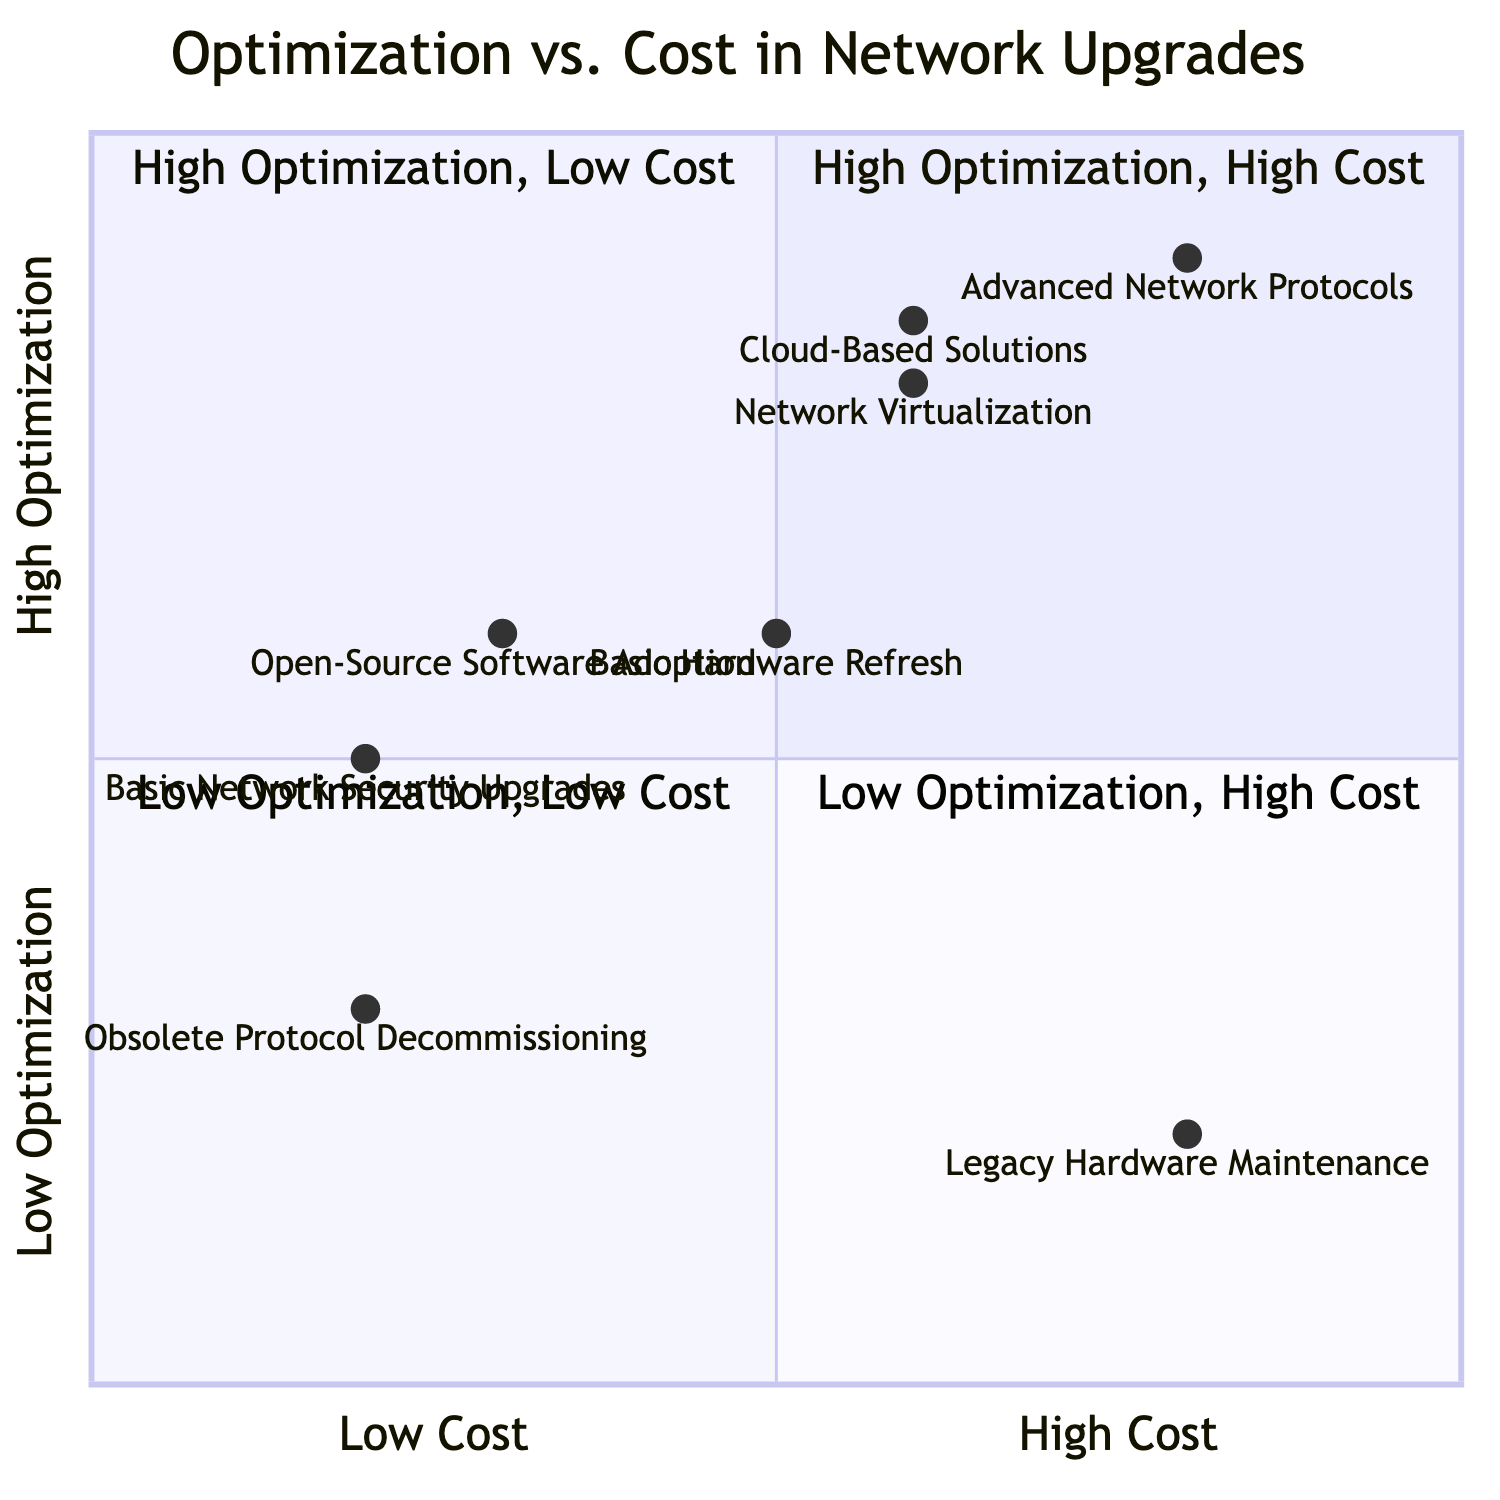What element is located in the High Optimization, High Cost quadrant? The diagram identifies "Advanced Network Protocols" as the only element in this quadrant.
Answer: Advanced Network Protocols How many elements fall under Low Cost? By examining the diagram, there are three elements: "Open-Source Software Adoption", "Obsolete Protocol Decommissioning", and "Basic Network Security Upgrades".
Answer: Three What is the optimization level of Cloud-Based Solutions? The diagram places "Cloud-Based Solutions" in the High Optimization category, indicating its performance advantages.
Answer: High Optimization Which element has the lowest optimization level and cost? The diagram shows "Obsolete Protocol Decommissioning" as the element positioned in the Low Optimization, Low Cost quadrant, reflecting its minimal investment and optimization impact.
Answer: Obsolete Protocol Decommissioning What is the cost level of Network Virtualization? In the diagram, "Network Virtualization" is listed under Medium Cost, placing it in an affordable range for network upgrades.
Answer: Medium Cost Which element has a Mid Optimization level and the highest cost? "Legacy Hardware Maintenance" is the sole element in the Low Optimization, High Cost quadrant, indicating that it has a higher cost without significant optimization benefits.
Answer: Legacy Hardware Maintenance How many elements are placed in the Low Optimization, High Cost quadrant? The diagram clearly identifies that there is one element, which is "Legacy Hardware Maintenance", in this quadrant.
Answer: One What is the optimization level of Basic Hardware Refresh? The "Basic Hardware Refresh" is categorized as Medium Optimization, indicating it offers a balance of investment and upgrade benefit.
Answer: Medium Optimization What is the cost level of Open-Source Software Adoption? The diagram indicates that "Open-Source Software Adoption" is categorized under Low Cost, which reflects its affordability for effective network optimization.
Answer: Low Cost 